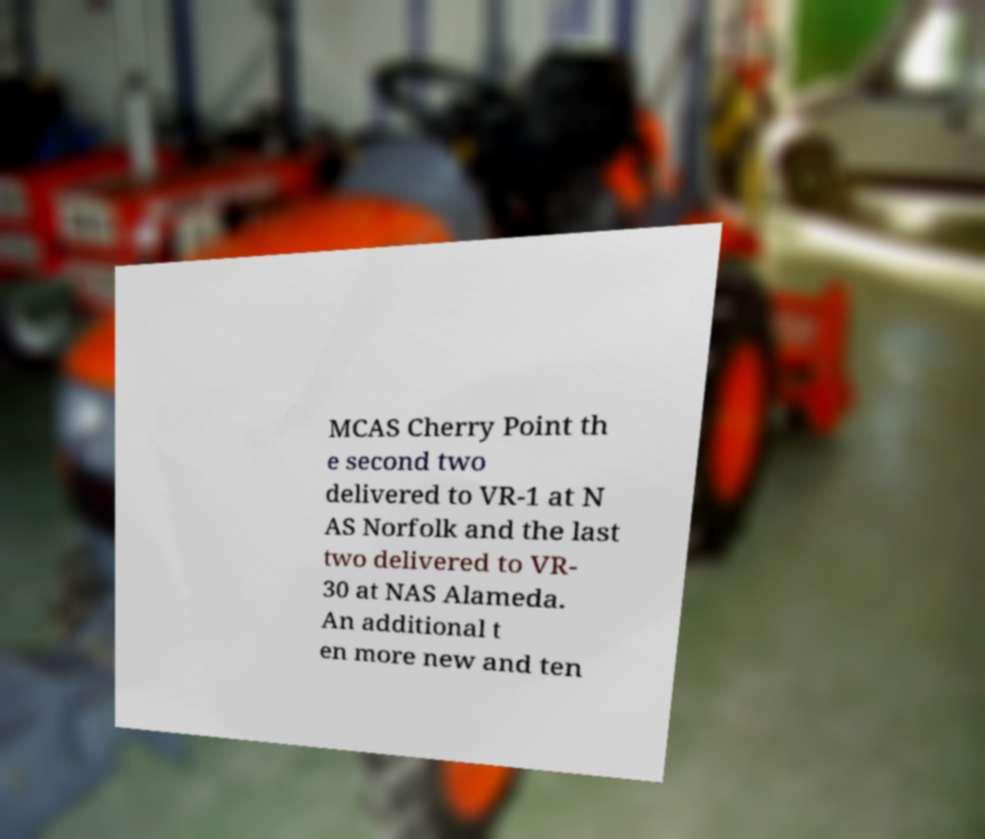Can you read and provide the text displayed in the image?This photo seems to have some interesting text. Can you extract and type it out for me? MCAS Cherry Point th e second two delivered to VR-1 at N AS Norfolk and the last two delivered to VR- 30 at NAS Alameda. An additional t en more new and ten 